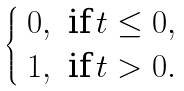<formula> <loc_0><loc_0><loc_500><loc_500>\begin{cases} \begin{array} { c c c } 0 , & \text {if} \, t \leq 0 , \\ 1 , & \text {if} \, t > 0 . \\ \end{array} \end{cases}</formula> 